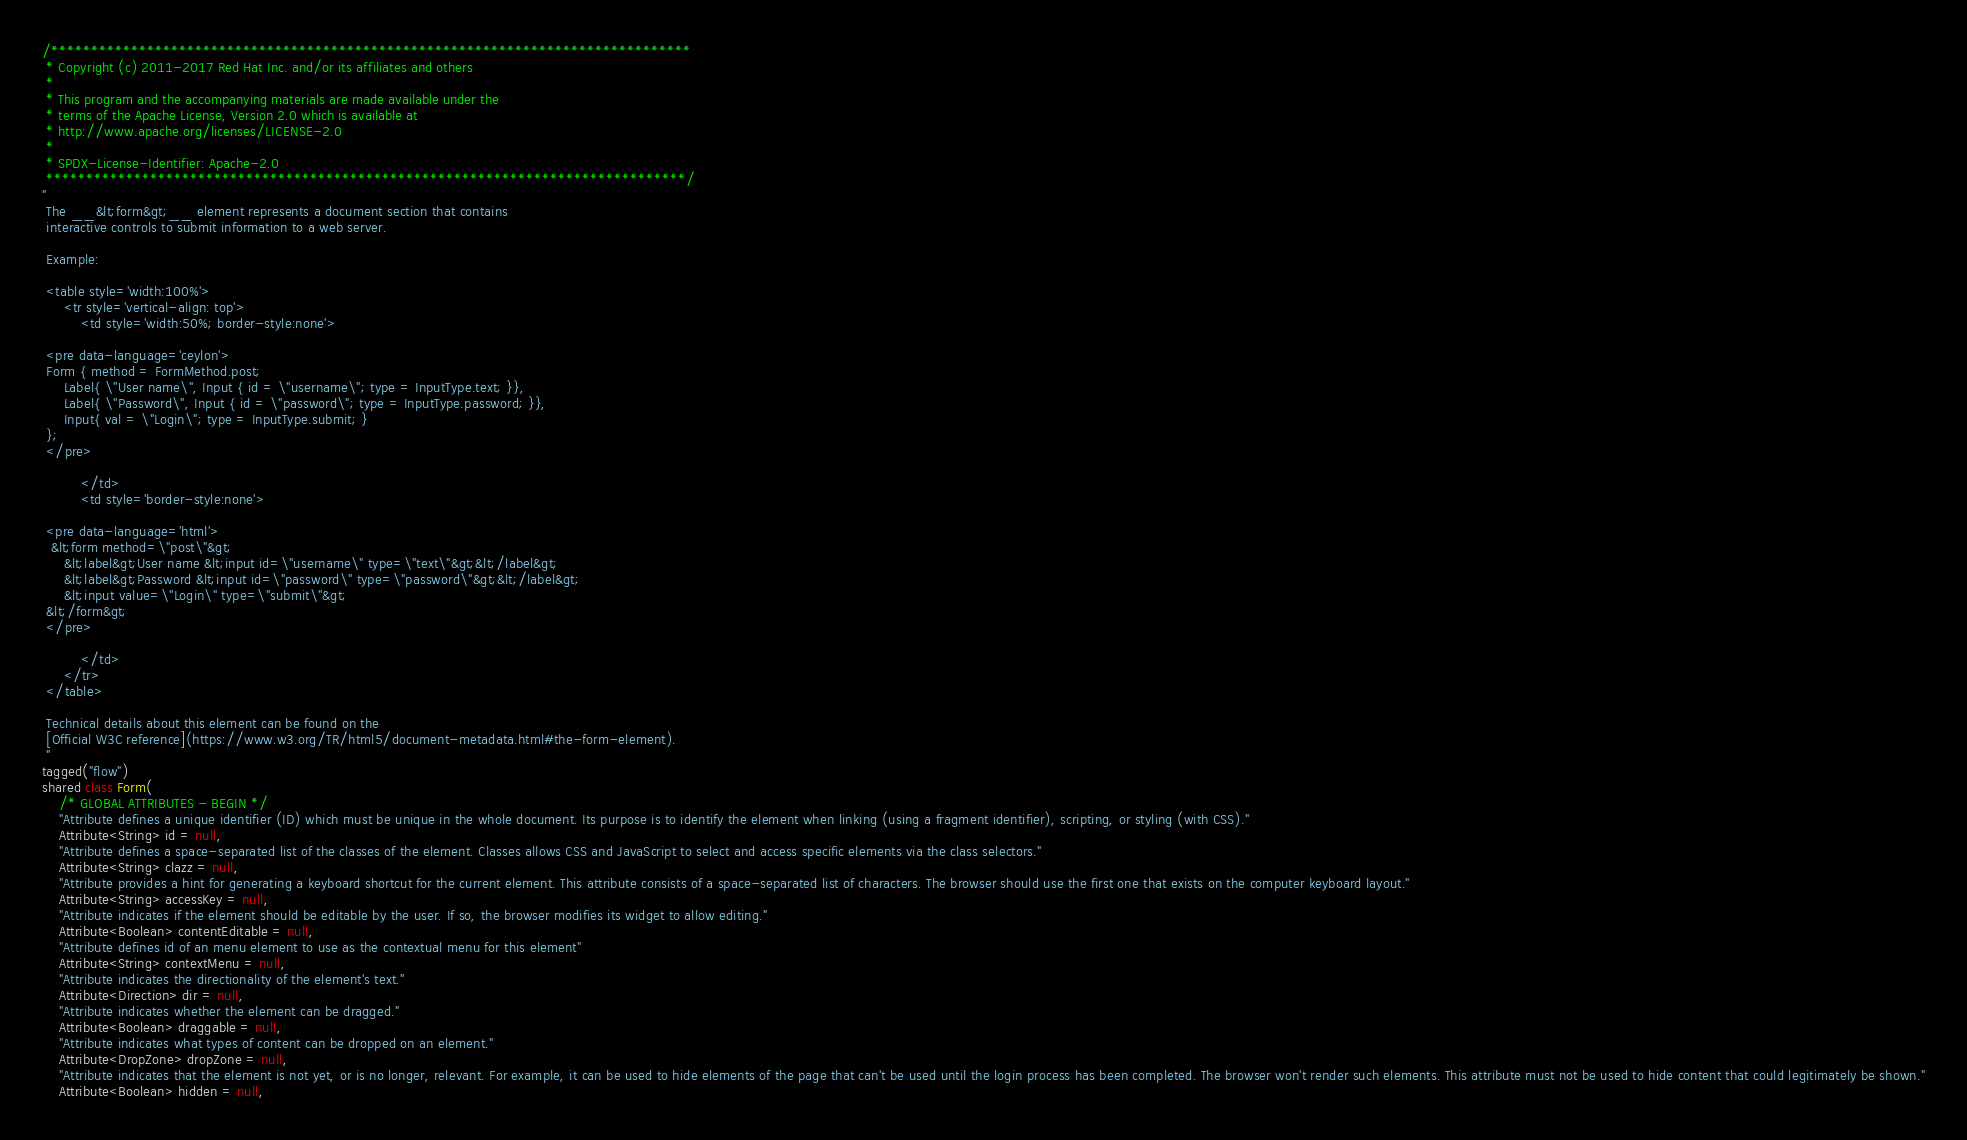Convert code to text. <code><loc_0><loc_0><loc_500><loc_500><_Ceylon_>/********************************************************************************
 * Copyright (c) 2011-2017 Red Hat Inc. and/or its affiliates and others
 *
 * This program and the accompanying materials are made available under the 
 * terms of the Apache License, Version 2.0 which is available at
 * http://www.apache.org/licenses/LICENSE-2.0
 *
 * SPDX-License-Identifier: Apache-2.0 
 ********************************************************************************/
"
 The __&lt;form&gt;__ element represents a document section that contains 
 interactive controls to submit information to a web server.
 
 Example:
 
 <table style='width:100%'>
     <tr style='vertical-align: top'>
         <td style='width:50%; border-style:none'>
         
 <pre data-language='ceylon'>
 Form { method = FormMethod.post;
     Label{ \"User name\", Input { id = \"username\"; type = InputType.text; }},
     Label{ \"Password\", Input { id = \"password\"; type = InputType.password; }},
     Input{ val = \"Login\"; type = InputType.submit; }
 };
 </pre>
 
         </td>
         <td style='border-style:none'>
         
 <pre data-language='html'>
  &lt;form method=\"post\"&gt;
     &lt;label&gt;User name &lt;input id=\"username\" type=\"text\"&gt;&lt;/label&gt;
     &lt;label&gt;Password &lt;input id=\"password\" type=\"password\"&gt;&lt;/label&gt;
     &lt;input value=\"Login\" type=\"submit\"&gt;
 &lt;/form&gt;
 </pre>
 
         </td>         
     </tr>
 </table>
 
 Technical details about this element can be found on the
 [Official W3C reference](https://www.w3.org/TR/html5/document-metadata.html#the-form-element).
 "
tagged("flow")
shared class Form(
    /* GLOBAL ATTRIBUTES - BEGIN */
    "Attribute defines a unique identifier (ID) which must be unique in the whole document. Its purpose is to identify the element when linking (using a fragment identifier), scripting, or styling (with CSS)."
    Attribute<String> id = null,
    "Attribute defines a space-separated list of the classes of the element. Classes allows CSS and JavaScript to select and access specific elements via the class selectors."
    Attribute<String> clazz = null,
    "Attribute provides a hint for generating a keyboard shortcut for the current element. This attribute consists of a space-separated list of characters. The browser should use the first one that exists on the computer keyboard layout."
    Attribute<String> accessKey = null,
    "Attribute indicates if the element should be editable by the user. If so, the browser modifies its widget to allow editing."
    Attribute<Boolean> contentEditable = null,
    "Attribute defines id of an menu element to use as the contextual menu for this element"
    Attribute<String> contextMenu = null,
    "Attribute indicates the directionality of the element's text."
    Attribute<Direction> dir = null,
    "Attribute indicates whether the element can be dragged."
    Attribute<Boolean> draggable = null,
    "Attribute indicates what types of content can be dropped on an element."
    Attribute<DropZone> dropZone = null,
    "Attribute indicates that the element is not yet, or is no longer, relevant. For example, it can be used to hide elements of the page that can't be used until the login process has been completed. The browser won't render such elements. This attribute must not be used to hide content that could legitimately be shown."
    Attribute<Boolean> hidden = null,</code> 